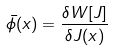Convert formula to latex. <formula><loc_0><loc_0><loc_500><loc_500>\bar { \phi } ( x ) = \frac { \delta W [ J ] } { \delta J ( x ) }</formula> 